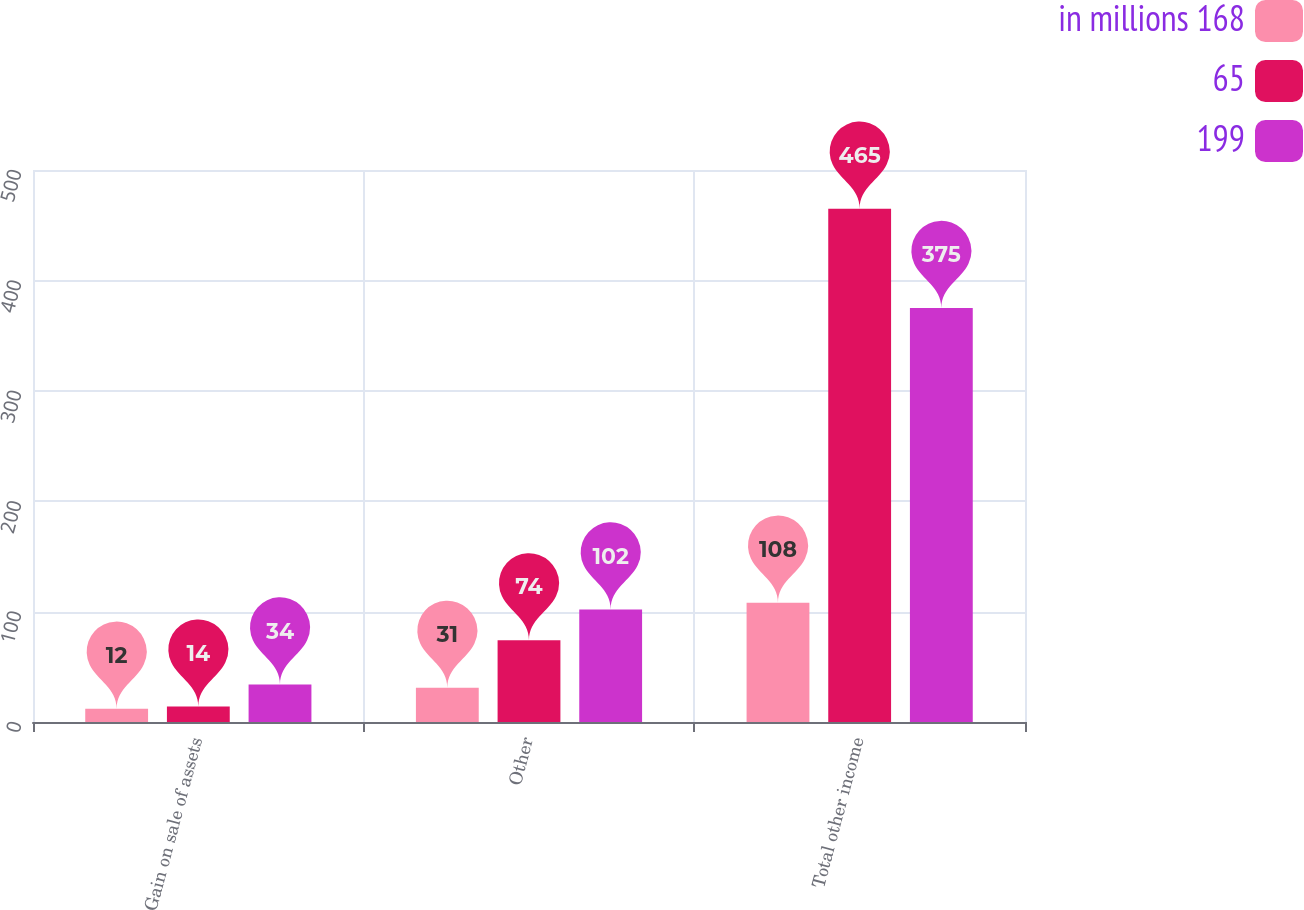Convert chart. <chart><loc_0><loc_0><loc_500><loc_500><stacked_bar_chart><ecel><fcel>Gain on sale of assets<fcel>Other<fcel>Total other income<nl><fcel>in millions 168<fcel>12<fcel>31<fcel>108<nl><fcel>65<fcel>14<fcel>74<fcel>465<nl><fcel>199<fcel>34<fcel>102<fcel>375<nl></chart> 